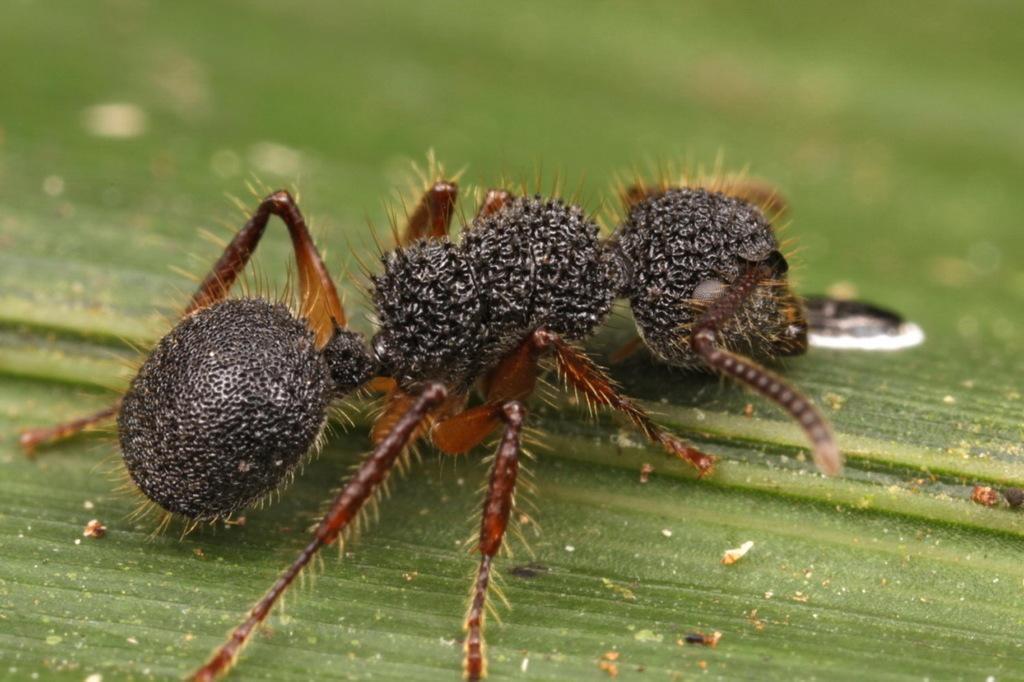In one or two sentences, can you explain what this image depicts? In this image we can see an insect on the leaf. This part of the image is blurred. 